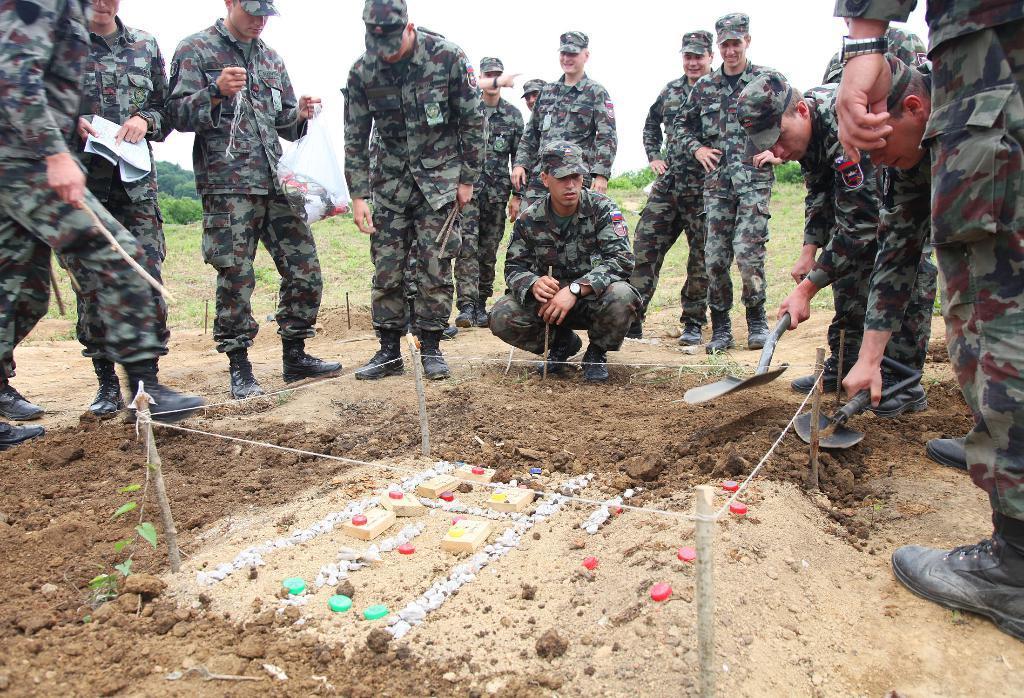Describe this image in one or two sentences. In this image we can see army people. At the bottom of the image, we can see the wooden pieces and some objects on the land. We can see two people are holding shovels in their hands. In the background of the image, we can see grassy land, plants and the sky. 